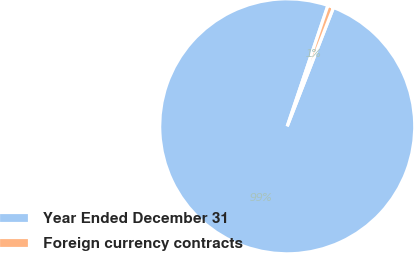<chart> <loc_0><loc_0><loc_500><loc_500><pie_chart><fcel>Year Ended December 31<fcel>Foreign currency contracts<nl><fcel>99.26%<fcel>0.74%<nl></chart> 